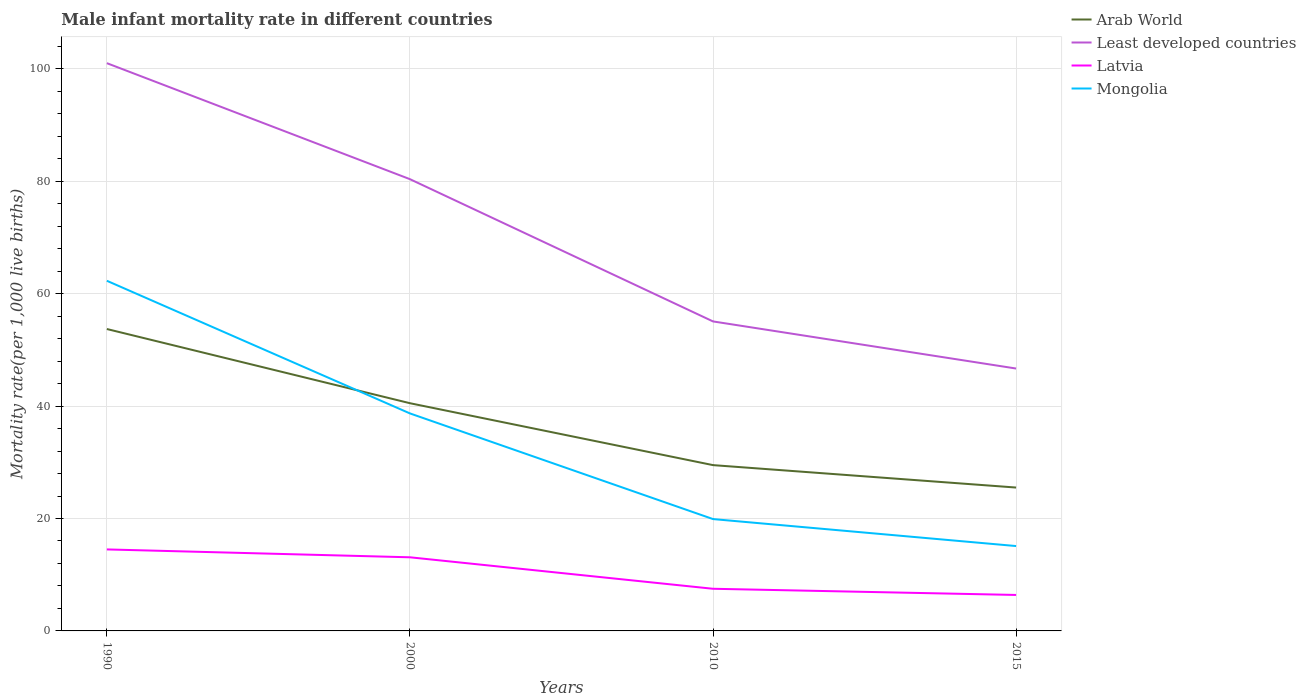How many different coloured lines are there?
Provide a short and direct response. 4. Is the number of lines equal to the number of legend labels?
Provide a succinct answer. Yes. In which year was the male infant mortality rate in Mongolia maximum?
Provide a succinct answer. 2015. What is the total male infant mortality rate in Latvia in the graph?
Your answer should be very brief. 1.1. What is the difference between the highest and the second highest male infant mortality rate in Least developed countries?
Your response must be concise. 54.33. What is the difference between the highest and the lowest male infant mortality rate in Arab World?
Your response must be concise. 2. Is the male infant mortality rate in Arab World strictly greater than the male infant mortality rate in Least developed countries over the years?
Offer a terse response. Yes. How many lines are there?
Keep it short and to the point. 4. Are the values on the major ticks of Y-axis written in scientific E-notation?
Make the answer very short. No. Does the graph contain any zero values?
Ensure brevity in your answer.  No. Where does the legend appear in the graph?
Your answer should be compact. Top right. How many legend labels are there?
Offer a very short reply. 4. What is the title of the graph?
Offer a very short reply. Male infant mortality rate in different countries. Does "Ireland" appear as one of the legend labels in the graph?
Give a very brief answer. No. What is the label or title of the Y-axis?
Offer a very short reply. Mortality rate(per 1,0 live births). What is the Mortality rate(per 1,000 live births) in Arab World in 1990?
Offer a terse response. 53.72. What is the Mortality rate(per 1,000 live births) of Least developed countries in 1990?
Give a very brief answer. 101.02. What is the Mortality rate(per 1,000 live births) in Mongolia in 1990?
Offer a terse response. 62.3. What is the Mortality rate(per 1,000 live births) in Arab World in 2000?
Your answer should be very brief. 40.52. What is the Mortality rate(per 1,000 live births) of Least developed countries in 2000?
Provide a succinct answer. 80.38. What is the Mortality rate(per 1,000 live births) in Mongolia in 2000?
Offer a terse response. 38.7. What is the Mortality rate(per 1,000 live births) in Arab World in 2010?
Keep it short and to the point. 29.5. What is the Mortality rate(per 1,000 live births) in Least developed countries in 2010?
Make the answer very short. 55.07. What is the Mortality rate(per 1,000 live births) of Mongolia in 2010?
Keep it short and to the point. 19.9. What is the Mortality rate(per 1,000 live births) in Arab World in 2015?
Provide a succinct answer. 25.51. What is the Mortality rate(per 1,000 live births) in Least developed countries in 2015?
Your answer should be very brief. 46.69. What is the Mortality rate(per 1,000 live births) in Mongolia in 2015?
Your answer should be very brief. 15.1. Across all years, what is the maximum Mortality rate(per 1,000 live births) in Arab World?
Offer a terse response. 53.72. Across all years, what is the maximum Mortality rate(per 1,000 live births) in Least developed countries?
Your answer should be very brief. 101.02. Across all years, what is the maximum Mortality rate(per 1,000 live births) of Latvia?
Your answer should be very brief. 14.5. Across all years, what is the maximum Mortality rate(per 1,000 live births) of Mongolia?
Keep it short and to the point. 62.3. Across all years, what is the minimum Mortality rate(per 1,000 live births) of Arab World?
Ensure brevity in your answer.  25.51. Across all years, what is the minimum Mortality rate(per 1,000 live births) in Least developed countries?
Your answer should be compact. 46.69. Across all years, what is the minimum Mortality rate(per 1,000 live births) of Latvia?
Make the answer very short. 6.4. What is the total Mortality rate(per 1,000 live births) of Arab World in the graph?
Give a very brief answer. 149.24. What is the total Mortality rate(per 1,000 live births) in Least developed countries in the graph?
Your response must be concise. 283.15. What is the total Mortality rate(per 1,000 live births) of Latvia in the graph?
Your response must be concise. 41.5. What is the total Mortality rate(per 1,000 live births) in Mongolia in the graph?
Provide a succinct answer. 136. What is the difference between the Mortality rate(per 1,000 live births) in Arab World in 1990 and that in 2000?
Provide a succinct answer. 13.2. What is the difference between the Mortality rate(per 1,000 live births) of Least developed countries in 1990 and that in 2000?
Ensure brevity in your answer.  20.64. What is the difference between the Mortality rate(per 1,000 live births) in Latvia in 1990 and that in 2000?
Ensure brevity in your answer.  1.4. What is the difference between the Mortality rate(per 1,000 live births) of Mongolia in 1990 and that in 2000?
Your answer should be compact. 23.6. What is the difference between the Mortality rate(per 1,000 live births) in Arab World in 1990 and that in 2010?
Offer a terse response. 24.22. What is the difference between the Mortality rate(per 1,000 live births) in Least developed countries in 1990 and that in 2010?
Your response must be concise. 45.95. What is the difference between the Mortality rate(per 1,000 live births) in Latvia in 1990 and that in 2010?
Provide a short and direct response. 7. What is the difference between the Mortality rate(per 1,000 live births) in Mongolia in 1990 and that in 2010?
Your response must be concise. 42.4. What is the difference between the Mortality rate(per 1,000 live births) of Arab World in 1990 and that in 2015?
Keep it short and to the point. 28.21. What is the difference between the Mortality rate(per 1,000 live births) in Least developed countries in 1990 and that in 2015?
Keep it short and to the point. 54.33. What is the difference between the Mortality rate(per 1,000 live births) in Mongolia in 1990 and that in 2015?
Your response must be concise. 47.2. What is the difference between the Mortality rate(per 1,000 live births) in Arab World in 2000 and that in 2010?
Provide a succinct answer. 11.02. What is the difference between the Mortality rate(per 1,000 live births) of Least developed countries in 2000 and that in 2010?
Make the answer very short. 25.31. What is the difference between the Mortality rate(per 1,000 live births) of Arab World in 2000 and that in 2015?
Keep it short and to the point. 15.01. What is the difference between the Mortality rate(per 1,000 live births) of Least developed countries in 2000 and that in 2015?
Your response must be concise. 33.69. What is the difference between the Mortality rate(per 1,000 live births) of Mongolia in 2000 and that in 2015?
Keep it short and to the point. 23.6. What is the difference between the Mortality rate(per 1,000 live births) in Arab World in 2010 and that in 2015?
Provide a short and direct response. 3.99. What is the difference between the Mortality rate(per 1,000 live births) of Least developed countries in 2010 and that in 2015?
Provide a succinct answer. 8.38. What is the difference between the Mortality rate(per 1,000 live births) in Mongolia in 2010 and that in 2015?
Make the answer very short. 4.8. What is the difference between the Mortality rate(per 1,000 live births) in Arab World in 1990 and the Mortality rate(per 1,000 live births) in Least developed countries in 2000?
Ensure brevity in your answer.  -26.66. What is the difference between the Mortality rate(per 1,000 live births) of Arab World in 1990 and the Mortality rate(per 1,000 live births) of Latvia in 2000?
Ensure brevity in your answer.  40.62. What is the difference between the Mortality rate(per 1,000 live births) in Arab World in 1990 and the Mortality rate(per 1,000 live births) in Mongolia in 2000?
Keep it short and to the point. 15.02. What is the difference between the Mortality rate(per 1,000 live births) of Least developed countries in 1990 and the Mortality rate(per 1,000 live births) of Latvia in 2000?
Your answer should be compact. 87.92. What is the difference between the Mortality rate(per 1,000 live births) of Least developed countries in 1990 and the Mortality rate(per 1,000 live births) of Mongolia in 2000?
Offer a terse response. 62.32. What is the difference between the Mortality rate(per 1,000 live births) of Latvia in 1990 and the Mortality rate(per 1,000 live births) of Mongolia in 2000?
Offer a very short reply. -24.2. What is the difference between the Mortality rate(per 1,000 live births) of Arab World in 1990 and the Mortality rate(per 1,000 live births) of Least developed countries in 2010?
Your answer should be very brief. -1.35. What is the difference between the Mortality rate(per 1,000 live births) of Arab World in 1990 and the Mortality rate(per 1,000 live births) of Latvia in 2010?
Provide a short and direct response. 46.22. What is the difference between the Mortality rate(per 1,000 live births) of Arab World in 1990 and the Mortality rate(per 1,000 live births) of Mongolia in 2010?
Your answer should be compact. 33.82. What is the difference between the Mortality rate(per 1,000 live births) of Least developed countries in 1990 and the Mortality rate(per 1,000 live births) of Latvia in 2010?
Offer a terse response. 93.52. What is the difference between the Mortality rate(per 1,000 live births) in Least developed countries in 1990 and the Mortality rate(per 1,000 live births) in Mongolia in 2010?
Provide a short and direct response. 81.12. What is the difference between the Mortality rate(per 1,000 live births) in Arab World in 1990 and the Mortality rate(per 1,000 live births) in Least developed countries in 2015?
Your response must be concise. 7.03. What is the difference between the Mortality rate(per 1,000 live births) in Arab World in 1990 and the Mortality rate(per 1,000 live births) in Latvia in 2015?
Your response must be concise. 47.32. What is the difference between the Mortality rate(per 1,000 live births) in Arab World in 1990 and the Mortality rate(per 1,000 live births) in Mongolia in 2015?
Your response must be concise. 38.62. What is the difference between the Mortality rate(per 1,000 live births) in Least developed countries in 1990 and the Mortality rate(per 1,000 live births) in Latvia in 2015?
Your answer should be compact. 94.62. What is the difference between the Mortality rate(per 1,000 live births) of Least developed countries in 1990 and the Mortality rate(per 1,000 live births) of Mongolia in 2015?
Provide a succinct answer. 85.92. What is the difference between the Mortality rate(per 1,000 live births) in Latvia in 1990 and the Mortality rate(per 1,000 live births) in Mongolia in 2015?
Ensure brevity in your answer.  -0.6. What is the difference between the Mortality rate(per 1,000 live births) in Arab World in 2000 and the Mortality rate(per 1,000 live births) in Least developed countries in 2010?
Offer a very short reply. -14.55. What is the difference between the Mortality rate(per 1,000 live births) in Arab World in 2000 and the Mortality rate(per 1,000 live births) in Latvia in 2010?
Provide a succinct answer. 33.02. What is the difference between the Mortality rate(per 1,000 live births) of Arab World in 2000 and the Mortality rate(per 1,000 live births) of Mongolia in 2010?
Your answer should be compact. 20.62. What is the difference between the Mortality rate(per 1,000 live births) of Least developed countries in 2000 and the Mortality rate(per 1,000 live births) of Latvia in 2010?
Provide a short and direct response. 72.88. What is the difference between the Mortality rate(per 1,000 live births) of Least developed countries in 2000 and the Mortality rate(per 1,000 live births) of Mongolia in 2010?
Provide a succinct answer. 60.48. What is the difference between the Mortality rate(per 1,000 live births) of Arab World in 2000 and the Mortality rate(per 1,000 live births) of Least developed countries in 2015?
Offer a very short reply. -6.17. What is the difference between the Mortality rate(per 1,000 live births) in Arab World in 2000 and the Mortality rate(per 1,000 live births) in Latvia in 2015?
Provide a succinct answer. 34.12. What is the difference between the Mortality rate(per 1,000 live births) in Arab World in 2000 and the Mortality rate(per 1,000 live births) in Mongolia in 2015?
Provide a short and direct response. 25.42. What is the difference between the Mortality rate(per 1,000 live births) of Least developed countries in 2000 and the Mortality rate(per 1,000 live births) of Latvia in 2015?
Offer a terse response. 73.98. What is the difference between the Mortality rate(per 1,000 live births) of Least developed countries in 2000 and the Mortality rate(per 1,000 live births) of Mongolia in 2015?
Give a very brief answer. 65.28. What is the difference between the Mortality rate(per 1,000 live births) of Arab World in 2010 and the Mortality rate(per 1,000 live births) of Least developed countries in 2015?
Ensure brevity in your answer.  -17.19. What is the difference between the Mortality rate(per 1,000 live births) in Arab World in 2010 and the Mortality rate(per 1,000 live births) in Latvia in 2015?
Give a very brief answer. 23.1. What is the difference between the Mortality rate(per 1,000 live births) in Arab World in 2010 and the Mortality rate(per 1,000 live births) in Mongolia in 2015?
Your answer should be very brief. 14.4. What is the difference between the Mortality rate(per 1,000 live births) in Least developed countries in 2010 and the Mortality rate(per 1,000 live births) in Latvia in 2015?
Provide a short and direct response. 48.67. What is the difference between the Mortality rate(per 1,000 live births) of Least developed countries in 2010 and the Mortality rate(per 1,000 live births) of Mongolia in 2015?
Keep it short and to the point. 39.97. What is the difference between the Mortality rate(per 1,000 live births) of Latvia in 2010 and the Mortality rate(per 1,000 live births) of Mongolia in 2015?
Your response must be concise. -7.6. What is the average Mortality rate(per 1,000 live births) of Arab World per year?
Offer a very short reply. 37.31. What is the average Mortality rate(per 1,000 live births) in Least developed countries per year?
Your response must be concise. 70.79. What is the average Mortality rate(per 1,000 live births) in Latvia per year?
Give a very brief answer. 10.38. In the year 1990, what is the difference between the Mortality rate(per 1,000 live births) in Arab World and Mortality rate(per 1,000 live births) in Least developed countries?
Offer a terse response. -47.3. In the year 1990, what is the difference between the Mortality rate(per 1,000 live births) in Arab World and Mortality rate(per 1,000 live births) in Latvia?
Your answer should be very brief. 39.22. In the year 1990, what is the difference between the Mortality rate(per 1,000 live births) in Arab World and Mortality rate(per 1,000 live births) in Mongolia?
Provide a short and direct response. -8.58. In the year 1990, what is the difference between the Mortality rate(per 1,000 live births) in Least developed countries and Mortality rate(per 1,000 live births) in Latvia?
Your answer should be very brief. 86.52. In the year 1990, what is the difference between the Mortality rate(per 1,000 live births) in Least developed countries and Mortality rate(per 1,000 live births) in Mongolia?
Your answer should be very brief. 38.72. In the year 1990, what is the difference between the Mortality rate(per 1,000 live births) in Latvia and Mortality rate(per 1,000 live births) in Mongolia?
Your answer should be very brief. -47.8. In the year 2000, what is the difference between the Mortality rate(per 1,000 live births) in Arab World and Mortality rate(per 1,000 live births) in Least developed countries?
Your answer should be very brief. -39.86. In the year 2000, what is the difference between the Mortality rate(per 1,000 live births) of Arab World and Mortality rate(per 1,000 live births) of Latvia?
Make the answer very short. 27.42. In the year 2000, what is the difference between the Mortality rate(per 1,000 live births) in Arab World and Mortality rate(per 1,000 live births) in Mongolia?
Your answer should be very brief. 1.82. In the year 2000, what is the difference between the Mortality rate(per 1,000 live births) in Least developed countries and Mortality rate(per 1,000 live births) in Latvia?
Ensure brevity in your answer.  67.28. In the year 2000, what is the difference between the Mortality rate(per 1,000 live births) of Least developed countries and Mortality rate(per 1,000 live births) of Mongolia?
Your response must be concise. 41.68. In the year 2000, what is the difference between the Mortality rate(per 1,000 live births) of Latvia and Mortality rate(per 1,000 live births) of Mongolia?
Provide a short and direct response. -25.6. In the year 2010, what is the difference between the Mortality rate(per 1,000 live births) of Arab World and Mortality rate(per 1,000 live births) of Least developed countries?
Keep it short and to the point. -25.57. In the year 2010, what is the difference between the Mortality rate(per 1,000 live births) of Arab World and Mortality rate(per 1,000 live births) of Mongolia?
Ensure brevity in your answer.  9.6. In the year 2010, what is the difference between the Mortality rate(per 1,000 live births) in Least developed countries and Mortality rate(per 1,000 live births) in Latvia?
Provide a short and direct response. 47.57. In the year 2010, what is the difference between the Mortality rate(per 1,000 live births) of Least developed countries and Mortality rate(per 1,000 live births) of Mongolia?
Offer a terse response. 35.17. In the year 2015, what is the difference between the Mortality rate(per 1,000 live births) of Arab World and Mortality rate(per 1,000 live births) of Least developed countries?
Offer a very short reply. -21.18. In the year 2015, what is the difference between the Mortality rate(per 1,000 live births) of Arab World and Mortality rate(per 1,000 live births) of Latvia?
Give a very brief answer. 19.11. In the year 2015, what is the difference between the Mortality rate(per 1,000 live births) in Arab World and Mortality rate(per 1,000 live births) in Mongolia?
Provide a succinct answer. 10.41. In the year 2015, what is the difference between the Mortality rate(per 1,000 live births) in Least developed countries and Mortality rate(per 1,000 live births) in Latvia?
Provide a succinct answer. 40.29. In the year 2015, what is the difference between the Mortality rate(per 1,000 live births) of Least developed countries and Mortality rate(per 1,000 live births) of Mongolia?
Make the answer very short. 31.59. What is the ratio of the Mortality rate(per 1,000 live births) in Arab World in 1990 to that in 2000?
Give a very brief answer. 1.33. What is the ratio of the Mortality rate(per 1,000 live births) in Least developed countries in 1990 to that in 2000?
Give a very brief answer. 1.26. What is the ratio of the Mortality rate(per 1,000 live births) in Latvia in 1990 to that in 2000?
Your answer should be compact. 1.11. What is the ratio of the Mortality rate(per 1,000 live births) of Mongolia in 1990 to that in 2000?
Offer a terse response. 1.61. What is the ratio of the Mortality rate(per 1,000 live births) in Arab World in 1990 to that in 2010?
Keep it short and to the point. 1.82. What is the ratio of the Mortality rate(per 1,000 live births) in Least developed countries in 1990 to that in 2010?
Offer a very short reply. 1.83. What is the ratio of the Mortality rate(per 1,000 live births) in Latvia in 1990 to that in 2010?
Keep it short and to the point. 1.93. What is the ratio of the Mortality rate(per 1,000 live births) of Mongolia in 1990 to that in 2010?
Your answer should be compact. 3.13. What is the ratio of the Mortality rate(per 1,000 live births) in Arab World in 1990 to that in 2015?
Give a very brief answer. 2.11. What is the ratio of the Mortality rate(per 1,000 live births) in Least developed countries in 1990 to that in 2015?
Keep it short and to the point. 2.16. What is the ratio of the Mortality rate(per 1,000 live births) in Latvia in 1990 to that in 2015?
Give a very brief answer. 2.27. What is the ratio of the Mortality rate(per 1,000 live births) in Mongolia in 1990 to that in 2015?
Provide a succinct answer. 4.13. What is the ratio of the Mortality rate(per 1,000 live births) of Arab World in 2000 to that in 2010?
Ensure brevity in your answer.  1.37. What is the ratio of the Mortality rate(per 1,000 live births) of Least developed countries in 2000 to that in 2010?
Your answer should be compact. 1.46. What is the ratio of the Mortality rate(per 1,000 live births) in Latvia in 2000 to that in 2010?
Offer a very short reply. 1.75. What is the ratio of the Mortality rate(per 1,000 live births) in Mongolia in 2000 to that in 2010?
Give a very brief answer. 1.94. What is the ratio of the Mortality rate(per 1,000 live births) in Arab World in 2000 to that in 2015?
Make the answer very short. 1.59. What is the ratio of the Mortality rate(per 1,000 live births) of Least developed countries in 2000 to that in 2015?
Offer a very short reply. 1.72. What is the ratio of the Mortality rate(per 1,000 live births) in Latvia in 2000 to that in 2015?
Your answer should be very brief. 2.05. What is the ratio of the Mortality rate(per 1,000 live births) of Mongolia in 2000 to that in 2015?
Ensure brevity in your answer.  2.56. What is the ratio of the Mortality rate(per 1,000 live births) in Arab World in 2010 to that in 2015?
Offer a very short reply. 1.16. What is the ratio of the Mortality rate(per 1,000 live births) of Least developed countries in 2010 to that in 2015?
Offer a terse response. 1.18. What is the ratio of the Mortality rate(per 1,000 live births) in Latvia in 2010 to that in 2015?
Your response must be concise. 1.17. What is the ratio of the Mortality rate(per 1,000 live births) in Mongolia in 2010 to that in 2015?
Make the answer very short. 1.32. What is the difference between the highest and the second highest Mortality rate(per 1,000 live births) of Arab World?
Provide a succinct answer. 13.2. What is the difference between the highest and the second highest Mortality rate(per 1,000 live births) in Least developed countries?
Your answer should be compact. 20.64. What is the difference between the highest and the second highest Mortality rate(per 1,000 live births) of Mongolia?
Give a very brief answer. 23.6. What is the difference between the highest and the lowest Mortality rate(per 1,000 live births) of Arab World?
Offer a very short reply. 28.21. What is the difference between the highest and the lowest Mortality rate(per 1,000 live births) of Least developed countries?
Give a very brief answer. 54.33. What is the difference between the highest and the lowest Mortality rate(per 1,000 live births) in Latvia?
Provide a short and direct response. 8.1. What is the difference between the highest and the lowest Mortality rate(per 1,000 live births) in Mongolia?
Offer a very short reply. 47.2. 